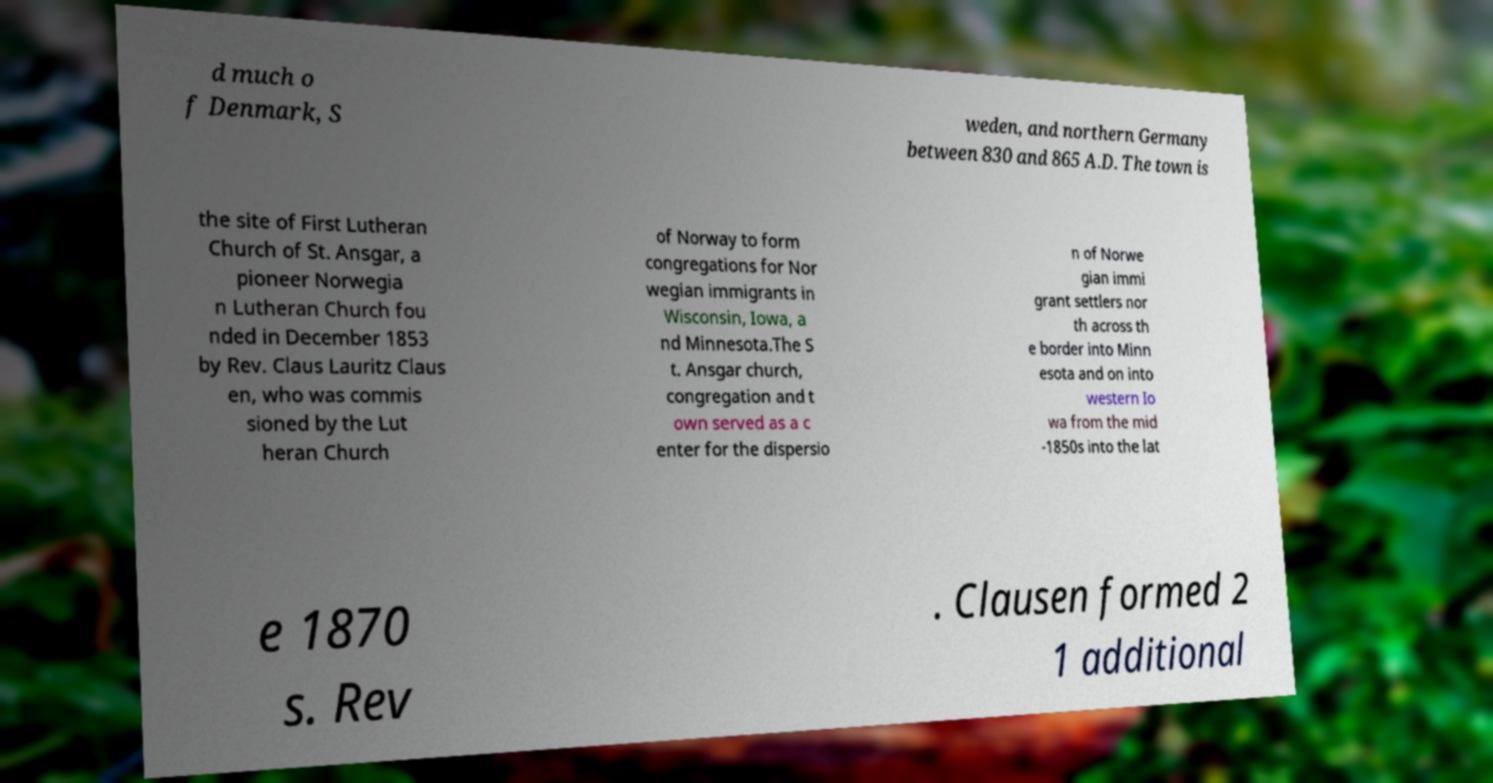Can you read and provide the text displayed in the image?This photo seems to have some interesting text. Can you extract and type it out for me? d much o f Denmark, S weden, and northern Germany between 830 and 865 A.D. The town is the site of First Lutheran Church of St. Ansgar, a pioneer Norwegia n Lutheran Church fou nded in December 1853 by Rev. Claus Lauritz Claus en, who was commis sioned by the Lut heran Church of Norway to form congregations for Nor wegian immigrants in Wisconsin, Iowa, a nd Minnesota.The S t. Ansgar church, congregation and t own served as a c enter for the dispersio n of Norwe gian immi grant settlers nor th across th e border into Minn esota and on into western Io wa from the mid -1850s into the lat e 1870 s. Rev . Clausen formed 2 1 additional 